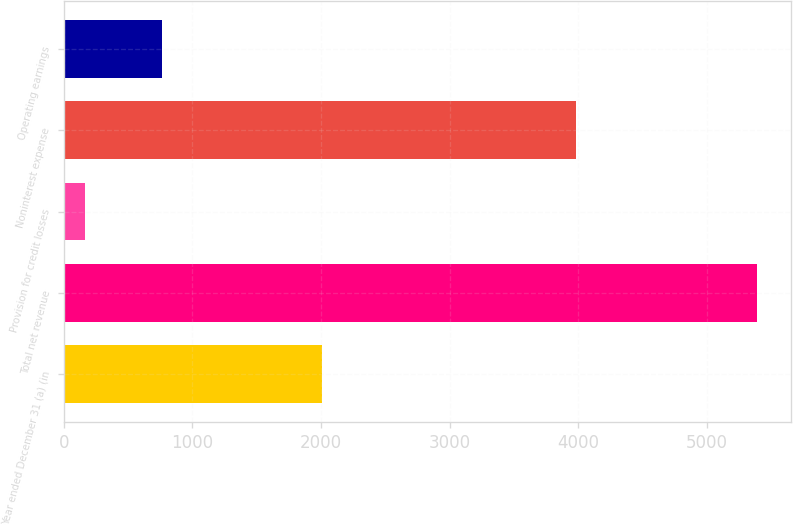Convert chart. <chart><loc_0><loc_0><loc_500><loc_500><bar_chart><fcel>Year ended December 31 (a) (in<fcel>Total net revenue<fcel>Provision for credit losses<fcel>Noninterest expense<fcel>Operating earnings<nl><fcel>2004<fcel>5385<fcel>165<fcel>3981<fcel>760<nl></chart> 